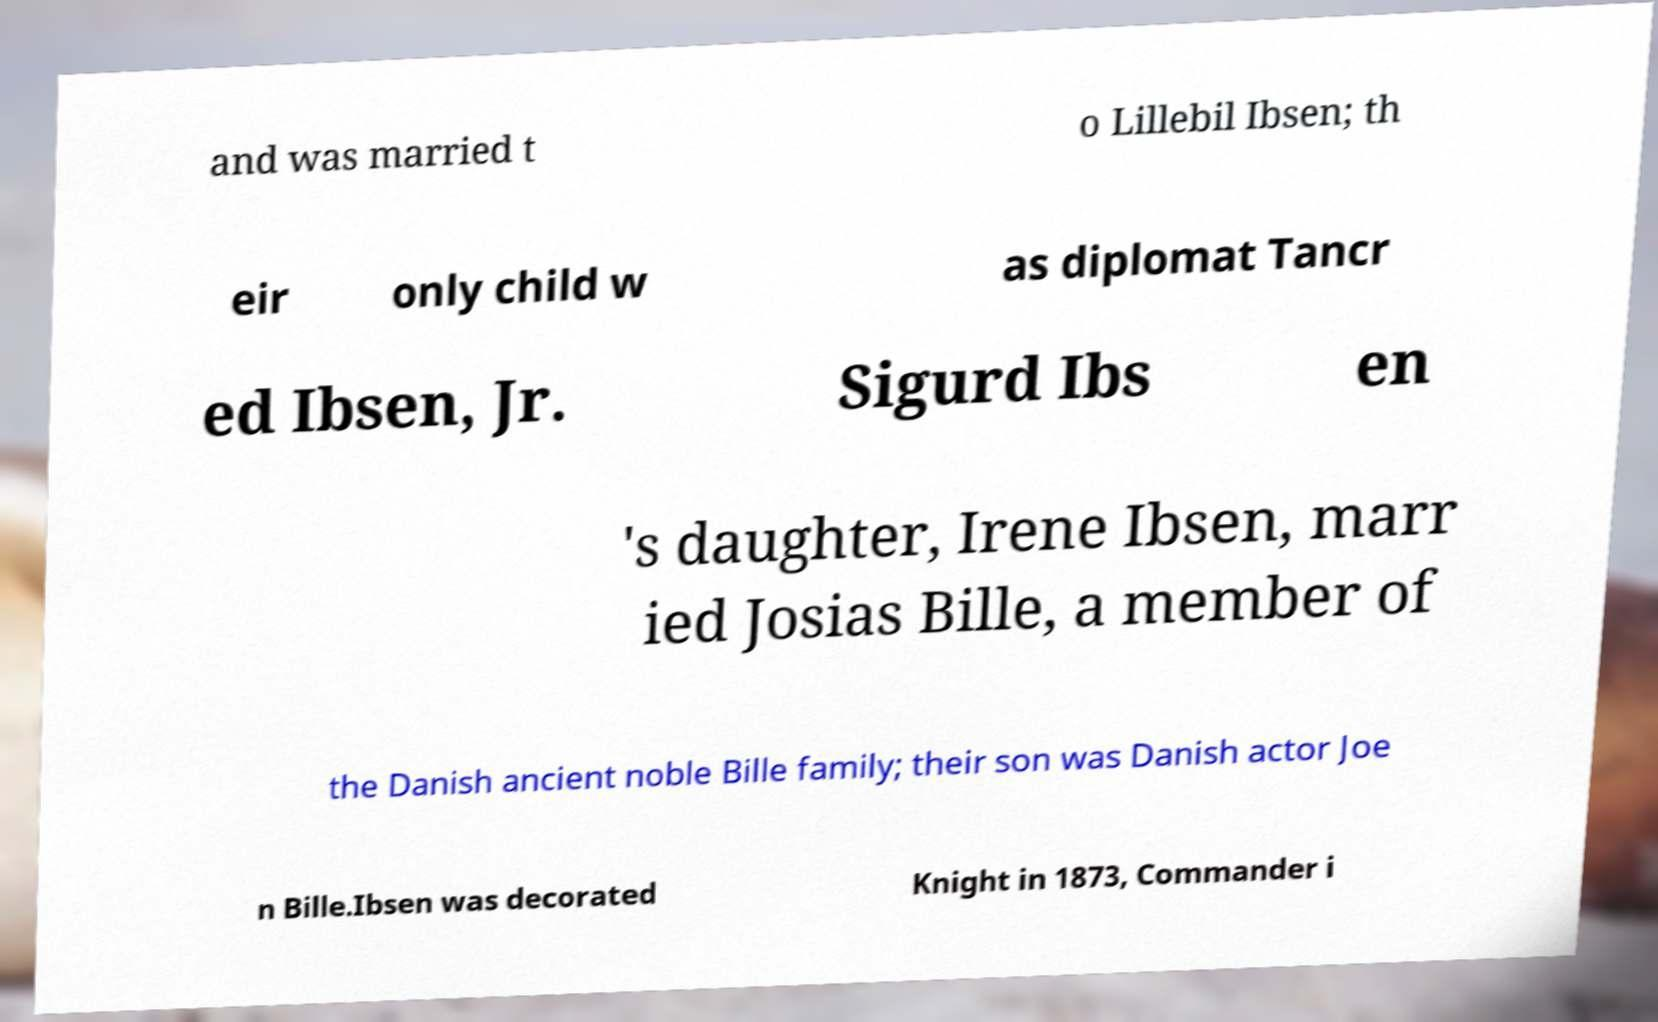What messages or text are displayed in this image? I need them in a readable, typed format. and was married t o Lillebil Ibsen; th eir only child w as diplomat Tancr ed Ibsen, Jr. Sigurd Ibs en 's daughter, Irene Ibsen, marr ied Josias Bille, a member of the Danish ancient noble Bille family; their son was Danish actor Joe n Bille.Ibsen was decorated Knight in 1873, Commander i 